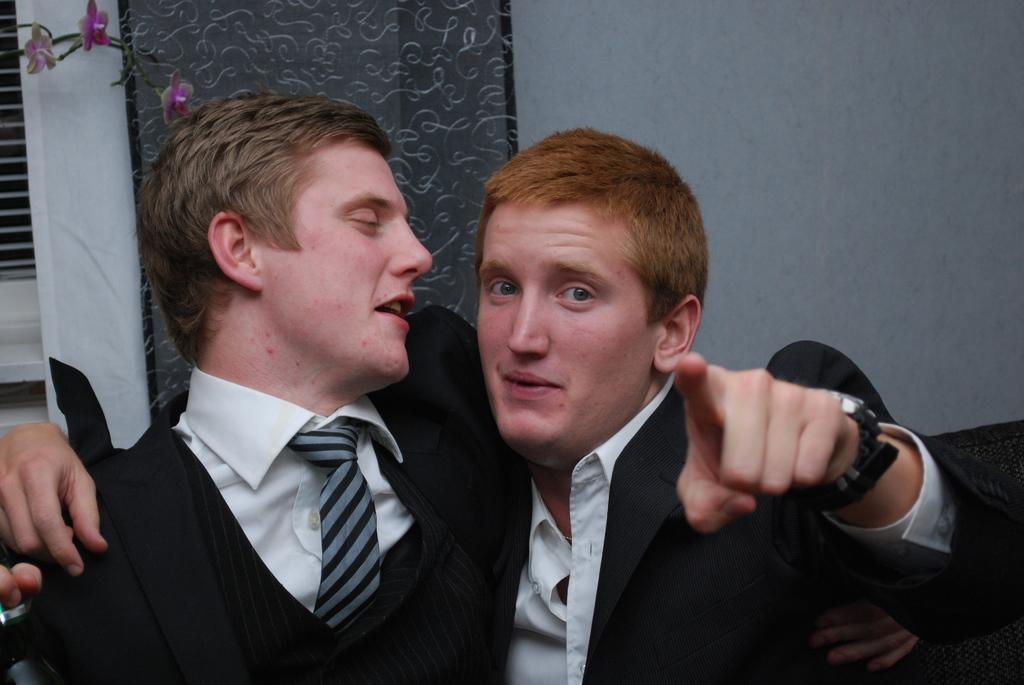Could you give a brief overview of what you see in this image? In this image we can see two men in a room and in the background there is a wall, window, curtain and artificial flowers. 